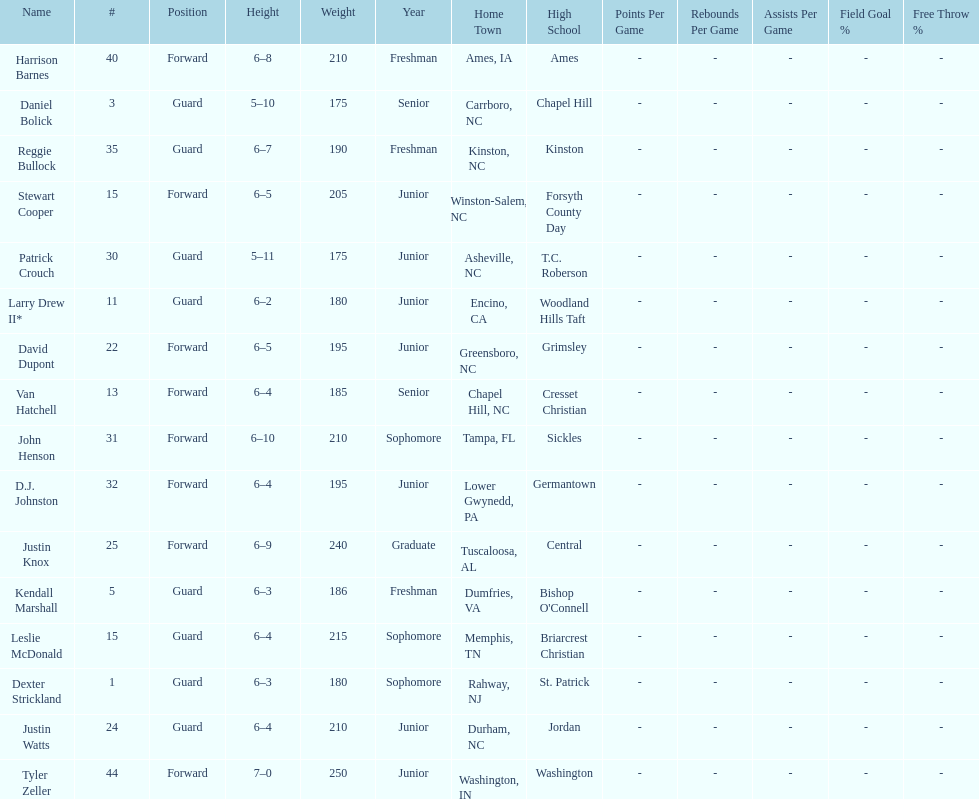Names of players who were exactly 6 feet, 4 inches tall, but did not weight over 200 pounds Van Hatchell, D.J. Johnston. 